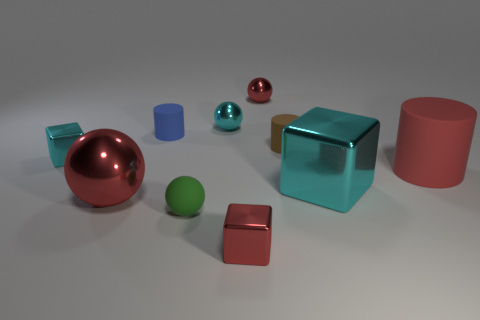Subtract all balls. How many objects are left? 6 Add 7 tiny cylinders. How many tiny cylinders exist? 9 Subtract 1 cyan balls. How many objects are left? 9 Subtract all tiny metallic things. Subtract all green things. How many objects are left? 5 Add 4 small spheres. How many small spheres are left? 7 